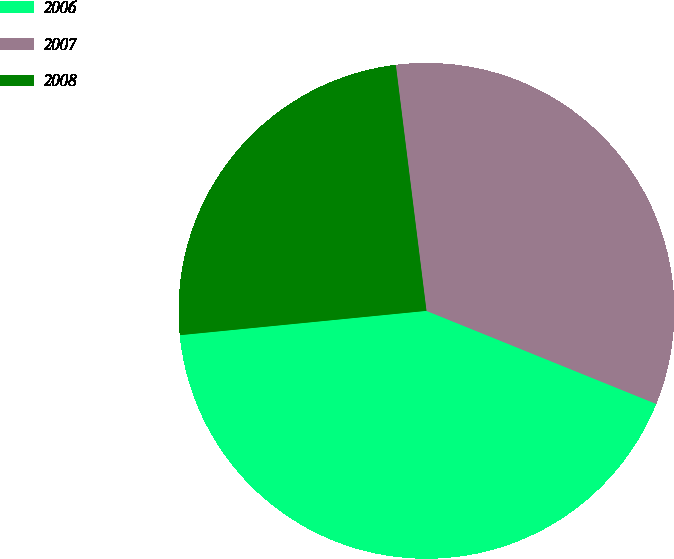Convert chart to OTSL. <chart><loc_0><loc_0><loc_500><loc_500><pie_chart><fcel>2006<fcel>2007<fcel>2008<nl><fcel>42.31%<fcel>33.1%<fcel>24.59%<nl></chart> 